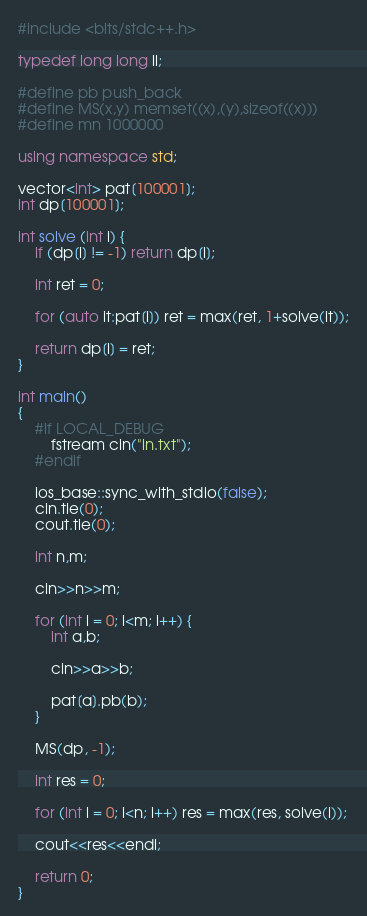Convert code to text. <code><loc_0><loc_0><loc_500><loc_500><_C++_>#include <bits/stdc++.h>

typedef long long ll;

#define pb push_back
#define MS(x,y) memset((x),(y),sizeof((x)))
#define mn 1000000

using namespace std;

vector<int> pat[100001];
int dp[100001];

int solve (int i) {
    if (dp[i] != -1) return dp[i];

    int ret = 0;

    for (auto it:pat[i]) ret = max(ret, 1+solve(it));

    return dp[i] = ret;
}

int main()
{
    #if LOCAL_DEBUG
        fstream cin("in.txt");
    #endif

    ios_base::sync_with_stdio(false);
    cin.tie(0);
    cout.tie(0);

    int n,m;

    cin>>n>>m;

    for (int i = 0; i<m; i++) {
        int a,b;

        cin>>a>>b;

        pat[a].pb(b);
    }

    MS(dp, -1);

    int res = 0;

    for (int i = 0; i<n; i++) res = max(res, solve(i));

    cout<<res<<endl;

    return 0;
}
</code> 